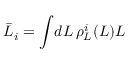Convert formula to latex. <formula><loc_0><loc_0><loc_500><loc_500>\bar { L } _ { i } = \int \, d L \, \rho _ { L } ^ { i } ( L ) L</formula> 